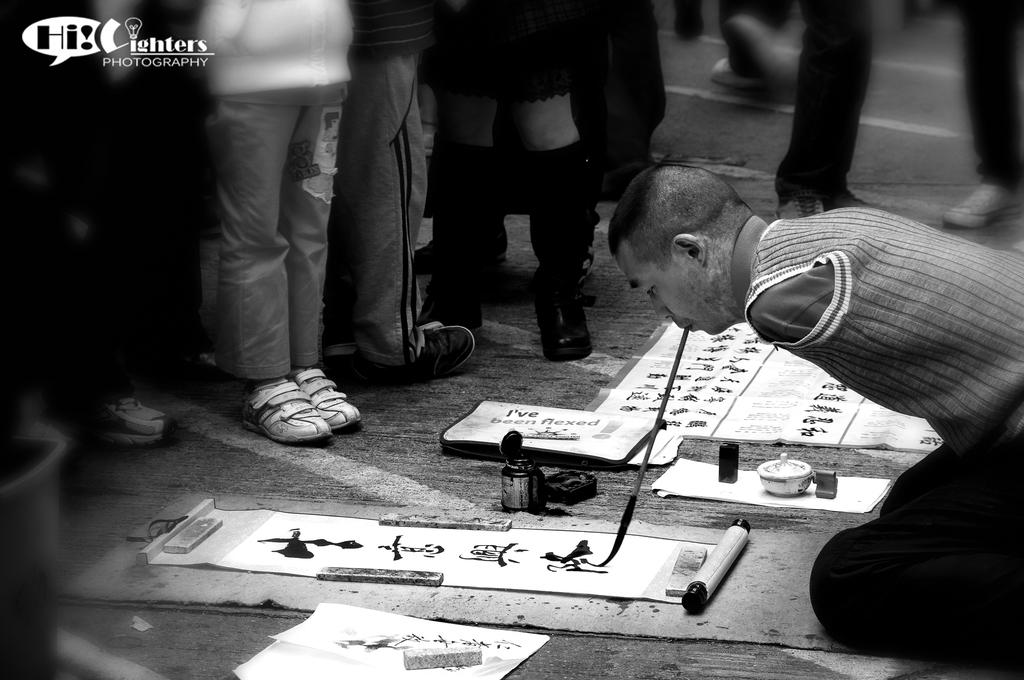What is the person in the image doing? The person is sitting on their knees and painting with a brush on paper. How is the person holding the brush? The person is using their mouth to paint. Are there any other people in the image? Yes, there are a few people standing in front of the person. What type of prose is the person reciting while painting in the image? There is no indication in the image that the person is reciting any prose while painting. 